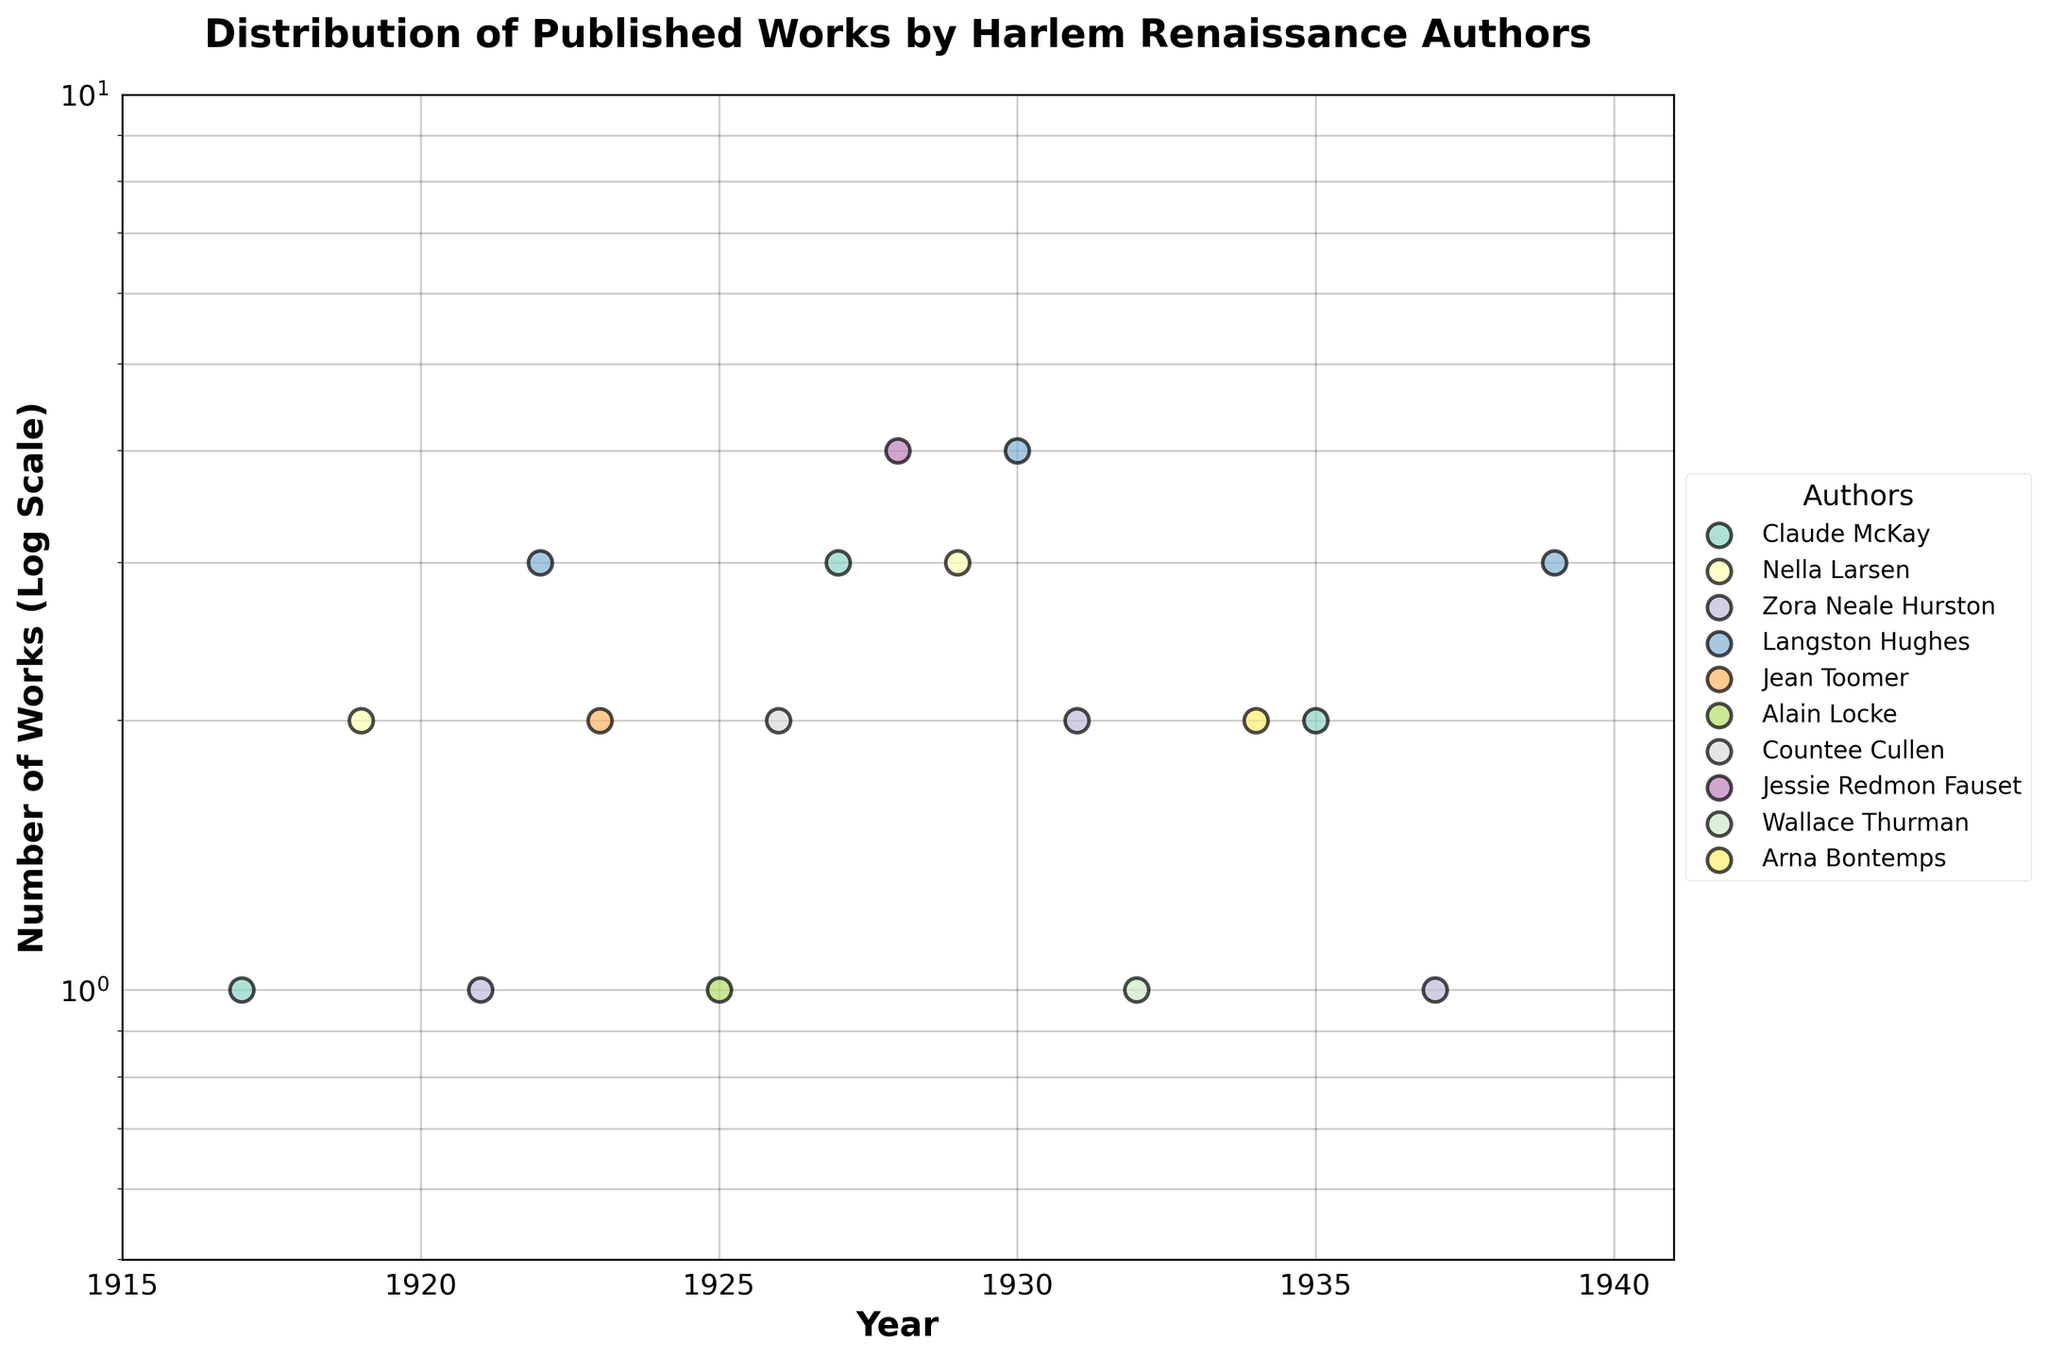What's the title of the plot? The title of the plot is located at the top and states the main subject of the figure.
Answer: Distribution of Published Works by Harlem Renaissance Authors What does the y-axis represent? The y-axis represents the number of works and uses a logarithmic scale to display the data.
Answer: Number of Works (Log Scale) Which author has published the most works in a single year, and how many works were published? By looking for the highest point on the y-axis, we see that Jessie Redmon Fauset has the highest single-year publication with 4 works in the year 1928.
Answer: Jessie Redmon Fauset, 4 works How many different authors' works are plotted in the figure? By noting the number of distinct colors/scatter labels in the legend, which corresponds to the unique authors, we count 11 authors.
Answer: 11 In what year did Claude McKay publish his highest number of works, and how many? By locating the points associated with Claude McKay and identifying the one with the highest y-value, we determine that in 1927, Claude McKay published 3 works.
Answer: 1927, 3 works Compare the number of works published by Langston Hughes and Zora Neale Hurston in 1931. Who published more? Identify the data points for both authors in 1931; Langston Hughes does not have a point in that year, while Zora Neale Hurston published 2 works. Thus, Zora Neale Hurston published more.
Answer: Zora Neale Hurston What is the range of years covered in the plot? The range of years can be determined from the x-axis, which shows data starting from 1917 to 1939.
Answer: 1917 to 1939 What's the total number of works published by Nella Larsen during the years shown? Locate all points for Nella Larsen, sum the number of works published in each year (2 in 1919 and 3 in 1929), resulting in a total of 5.
Answer: 5 Which two authors have the same number of publications in 1923, and what is this number? Identify the points for the year 1923. Both Zora Neale Hurston and Jean Toomer published the same number of works. Each of them published 2 works.
Answer: Zora Neale Hurston and Jean Toomer, 2 works How many years are represented in the scatter plot? Count the unique years shown along the x-axis for the data points; the plot covers 14 unique years (from 1917 to 1939).
Answer: 14 